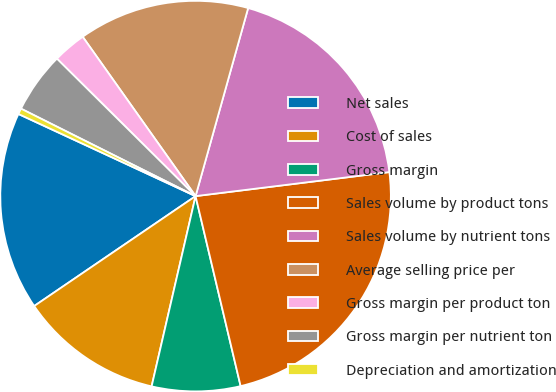Convert chart. <chart><loc_0><loc_0><loc_500><loc_500><pie_chart><fcel>Net sales<fcel>Cost of sales<fcel>Gross margin<fcel>Sales volume by product tons<fcel>Sales volume by nutrient tons<fcel>Average selling price per<fcel>Gross margin per product ton<fcel>Gross margin per nutrient ton<fcel>Depreciation and amortization<nl><fcel>16.43%<fcel>11.87%<fcel>7.32%<fcel>23.26%<fcel>18.7%<fcel>14.15%<fcel>2.76%<fcel>5.04%<fcel>0.48%<nl></chart> 